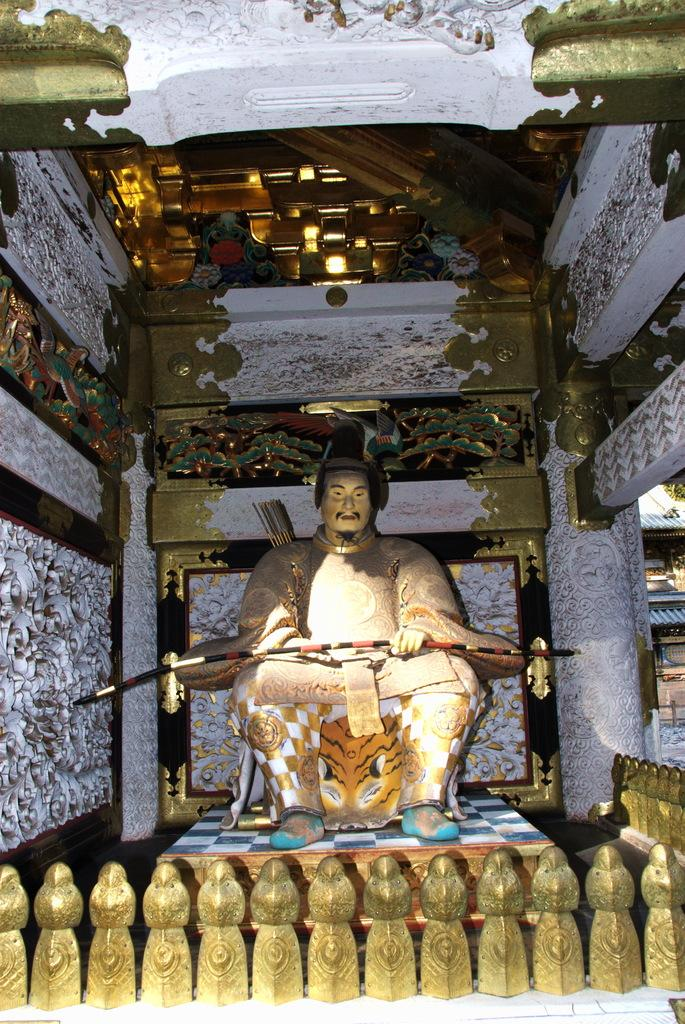What is the main subject of the image? The main subject of the image is a person's statue. What is the statue holding? The statue is holding a bow. What position is the statue in? The statue is sitting on a chair. Where is the statue located? The statue is on a stage. What is in front of the statue? There is a fencing in front of the statue. What can be seen in the background of the image? There is a wall and a roof in the background of the image. What type of humor can be seen in the statue's expression in the image? There is no indication of humor or expression in the statue's face, as it is a statue and not a living person. 